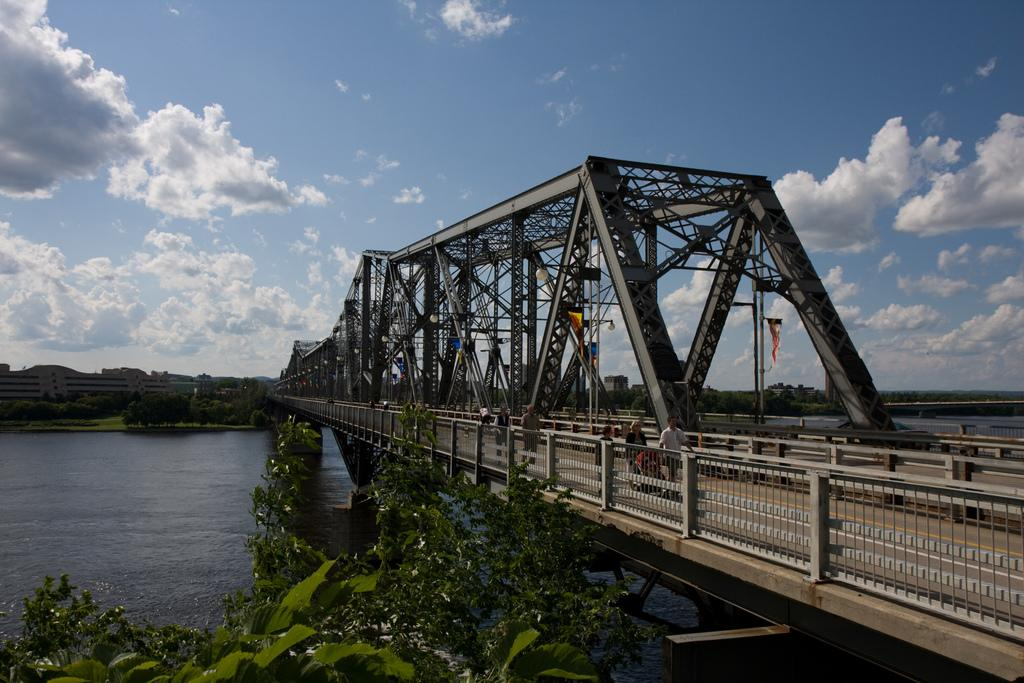Who is present in the image? There are people in the image. What are the people doing in the image? The people are walking on a bridge. What can be seen in the image besides the people and the bridge? There are flags, trees, and a river visible in the image. How would you describe the weather in the image? The sky is cloudy in the image. What type of door can be seen in the image? There is no door present in the image. What kind of battle is taking place in the image? There is no battle depicted in the image; it features people walking on a bridge. 